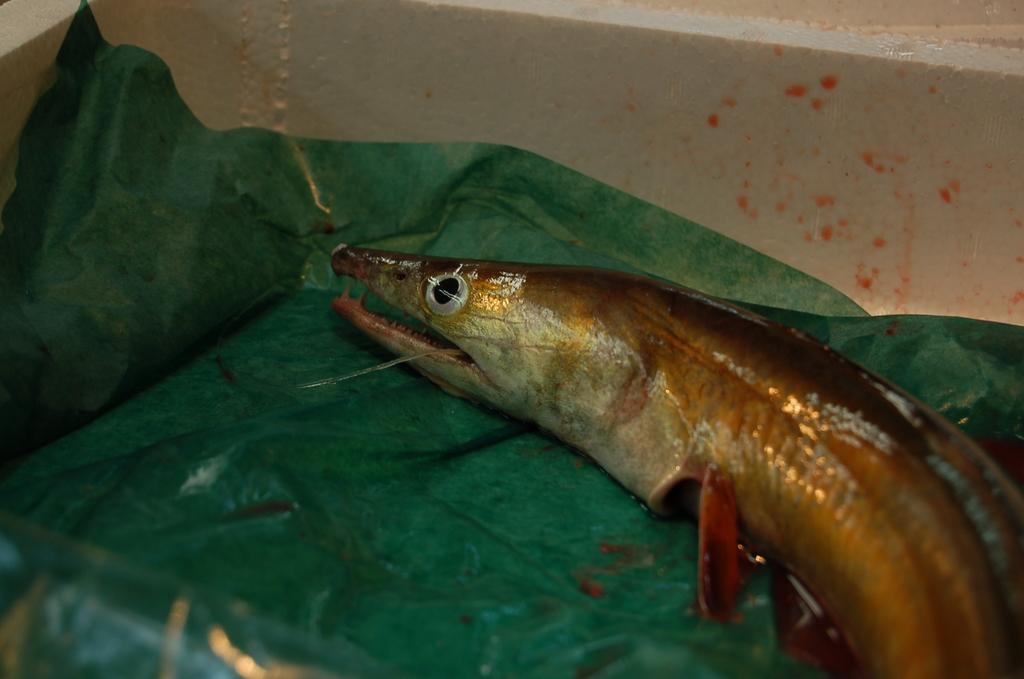What is the color of the surface in the image? The surface in the image is green. What can be found on the green surface? There is a fish on the green surface. What type of trouble is the fish causing in the image? There is no indication of trouble in the image; the fish is simply on the green surface. What scent can be detected from the fish in the image? There is no mention of scent in the image, and it is not possible to detect a scent from a two-dimensional image. 